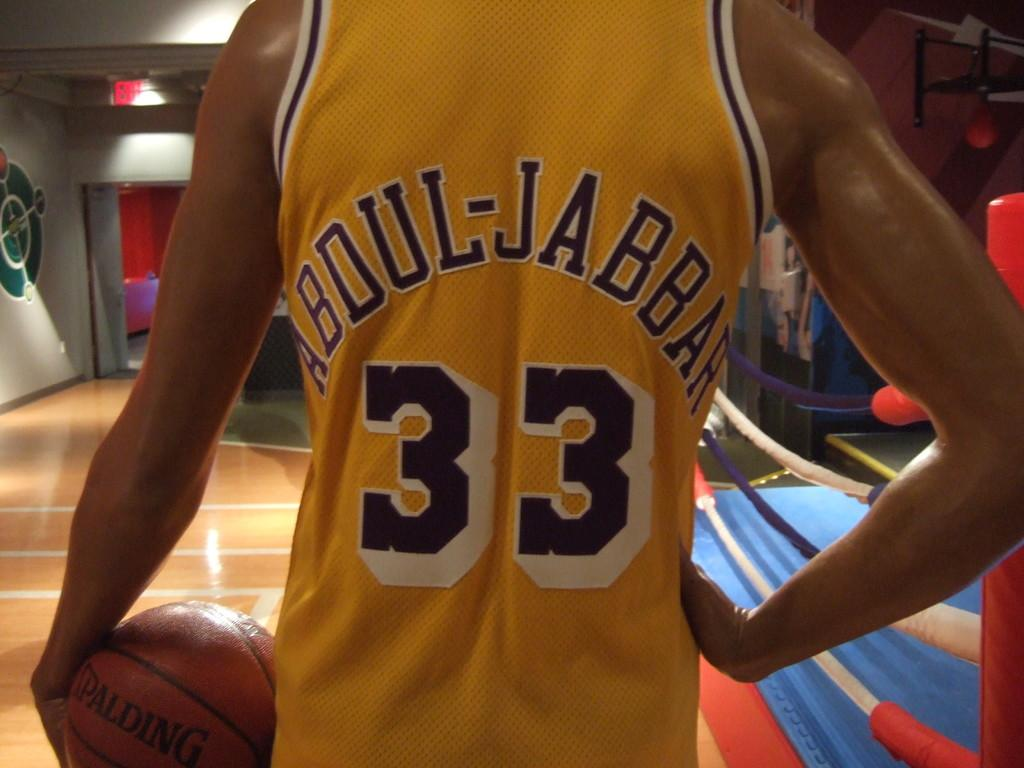<image>
Give a short and clear explanation of the subsequent image. A person holding a basketball and wearing a Abdul-Jabbar jersey. 